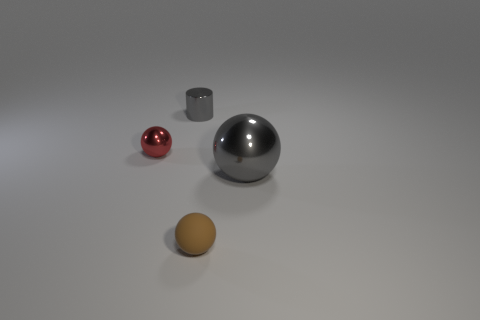What number of other objects are the same size as the red sphere?
Make the answer very short. 2. There is a small object that is on the left side of the gray thing to the left of the big ball; is there a tiny gray shiny thing in front of it?
Keep it short and to the point. No. What is the size of the cylinder?
Ensure brevity in your answer.  Small. How big is the metal sphere that is left of the small metal cylinder?
Your answer should be very brief. Small. Does the metallic object that is on the right side of the shiny cylinder have the same size as the tiny gray object?
Your answer should be very brief. No. Are there any other things of the same color as the rubber thing?
Provide a short and direct response. No. There is a tiny red thing; what shape is it?
Offer a very short reply. Sphere. How many things are to the left of the big gray shiny ball and in front of the small red metal sphere?
Keep it short and to the point. 1. Is the color of the small matte object the same as the large thing?
Give a very brief answer. No. There is another brown thing that is the same shape as the large shiny thing; what material is it?
Make the answer very short. Rubber. 